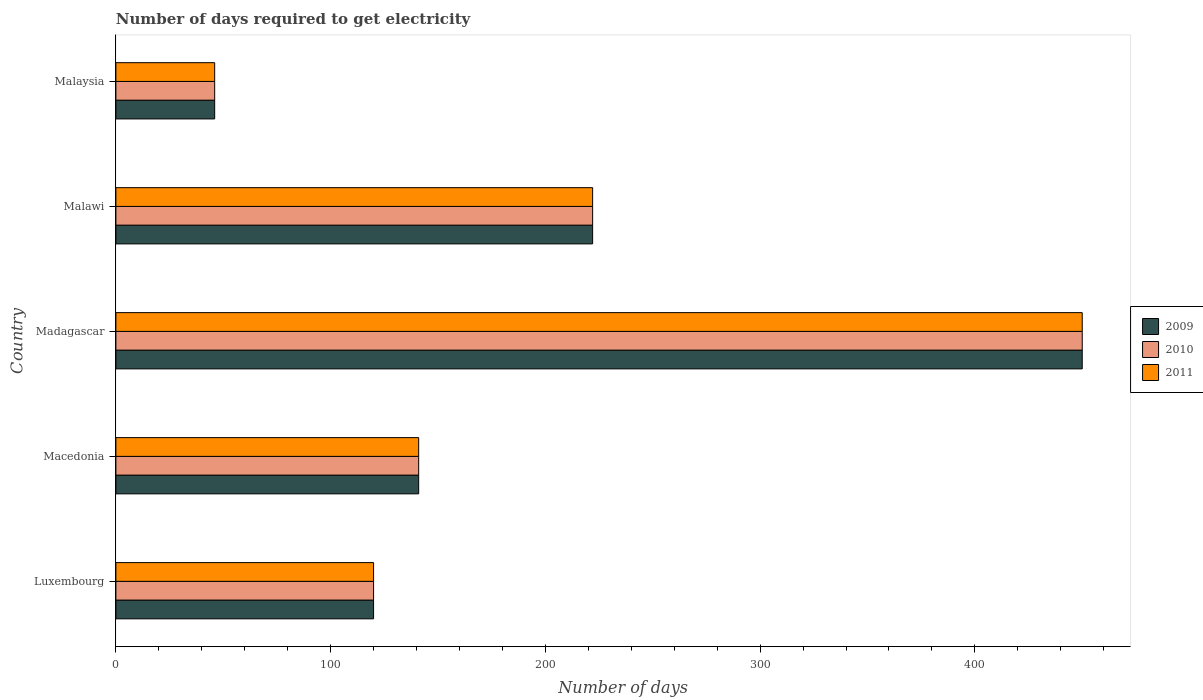How many different coloured bars are there?
Make the answer very short. 3. How many groups of bars are there?
Provide a short and direct response. 5. Are the number of bars per tick equal to the number of legend labels?
Offer a very short reply. Yes. Are the number of bars on each tick of the Y-axis equal?
Give a very brief answer. Yes. What is the label of the 5th group of bars from the top?
Provide a short and direct response. Luxembourg. In how many cases, is the number of bars for a given country not equal to the number of legend labels?
Offer a terse response. 0. Across all countries, what is the maximum number of days required to get electricity in in 2011?
Ensure brevity in your answer.  450. In which country was the number of days required to get electricity in in 2010 maximum?
Keep it short and to the point. Madagascar. In which country was the number of days required to get electricity in in 2011 minimum?
Ensure brevity in your answer.  Malaysia. What is the total number of days required to get electricity in in 2011 in the graph?
Keep it short and to the point. 979. What is the difference between the number of days required to get electricity in in 2010 in Luxembourg and that in Macedonia?
Provide a succinct answer. -21. What is the difference between the number of days required to get electricity in in 2011 in Malaysia and the number of days required to get electricity in in 2009 in Macedonia?
Ensure brevity in your answer.  -95. What is the average number of days required to get electricity in in 2010 per country?
Your answer should be very brief. 195.8. What is the ratio of the number of days required to get electricity in in 2010 in Madagascar to that in Malaysia?
Make the answer very short. 9.78. What is the difference between the highest and the second highest number of days required to get electricity in in 2010?
Your response must be concise. 228. What is the difference between the highest and the lowest number of days required to get electricity in in 2010?
Give a very brief answer. 404. What does the 2nd bar from the bottom in Malaysia represents?
Offer a terse response. 2010. Is it the case that in every country, the sum of the number of days required to get electricity in in 2009 and number of days required to get electricity in in 2010 is greater than the number of days required to get electricity in in 2011?
Keep it short and to the point. Yes. How many bars are there?
Make the answer very short. 15. Are all the bars in the graph horizontal?
Make the answer very short. Yes. What is the difference between two consecutive major ticks on the X-axis?
Your answer should be very brief. 100. Are the values on the major ticks of X-axis written in scientific E-notation?
Make the answer very short. No. Does the graph contain any zero values?
Offer a very short reply. No. Does the graph contain grids?
Your answer should be compact. No. What is the title of the graph?
Your answer should be very brief. Number of days required to get electricity. Does "2009" appear as one of the legend labels in the graph?
Your response must be concise. Yes. What is the label or title of the X-axis?
Offer a terse response. Number of days. What is the label or title of the Y-axis?
Your answer should be compact. Country. What is the Number of days in 2009 in Luxembourg?
Your answer should be compact. 120. What is the Number of days in 2010 in Luxembourg?
Make the answer very short. 120. What is the Number of days of 2011 in Luxembourg?
Give a very brief answer. 120. What is the Number of days in 2009 in Macedonia?
Offer a very short reply. 141. What is the Number of days in 2010 in Macedonia?
Provide a short and direct response. 141. What is the Number of days of 2011 in Macedonia?
Give a very brief answer. 141. What is the Number of days of 2009 in Madagascar?
Make the answer very short. 450. What is the Number of days of 2010 in Madagascar?
Offer a very short reply. 450. What is the Number of days of 2011 in Madagascar?
Your response must be concise. 450. What is the Number of days of 2009 in Malawi?
Your response must be concise. 222. What is the Number of days of 2010 in Malawi?
Give a very brief answer. 222. What is the Number of days of 2011 in Malawi?
Your answer should be compact. 222. What is the Number of days in 2009 in Malaysia?
Give a very brief answer. 46. What is the Number of days of 2010 in Malaysia?
Your response must be concise. 46. Across all countries, what is the maximum Number of days of 2009?
Your answer should be very brief. 450. Across all countries, what is the maximum Number of days in 2010?
Make the answer very short. 450. Across all countries, what is the maximum Number of days in 2011?
Keep it short and to the point. 450. Across all countries, what is the minimum Number of days in 2010?
Provide a short and direct response. 46. What is the total Number of days of 2009 in the graph?
Keep it short and to the point. 979. What is the total Number of days of 2010 in the graph?
Provide a succinct answer. 979. What is the total Number of days in 2011 in the graph?
Ensure brevity in your answer.  979. What is the difference between the Number of days in 2009 in Luxembourg and that in Madagascar?
Your response must be concise. -330. What is the difference between the Number of days of 2010 in Luxembourg and that in Madagascar?
Your response must be concise. -330. What is the difference between the Number of days of 2011 in Luxembourg and that in Madagascar?
Your answer should be very brief. -330. What is the difference between the Number of days in 2009 in Luxembourg and that in Malawi?
Offer a terse response. -102. What is the difference between the Number of days of 2010 in Luxembourg and that in Malawi?
Your answer should be very brief. -102. What is the difference between the Number of days in 2011 in Luxembourg and that in Malawi?
Make the answer very short. -102. What is the difference between the Number of days in 2010 in Luxembourg and that in Malaysia?
Your answer should be compact. 74. What is the difference between the Number of days of 2009 in Macedonia and that in Madagascar?
Your response must be concise. -309. What is the difference between the Number of days in 2010 in Macedonia and that in Madagascar?
Keep it short and to the point. -309. What is the difference between the Number of days of 2011 in Macedonia and that in Madagascar?
Offer a terse response. -309. What is the difference between the Number of days in 2009 in Macedonia and that in Malawi?
Offer a very short reply. -81. What is the difference between the Number of days in 2010 in Macedonia and that in Malawi?
Offer a terse response. -81. What is the difference between the Number of days of 2011 in Macedonia and that in Malawi?
Offer a very short reply. -81. What is the difference between the Number of days in 2010 in Macedonia and that in Malaysia?
Offer a terse response. 95. What is the difference between the Number of days of 2011 in Macedonia and that in Malaysia?
Provide a succinct answer. 95. What is the difference between the Number of days of 2009 in Madagascar and that in Malawi?
Give a very brief answer. 228. What is the difference between the Number of days of 2010 in Madagascar and that in Malawi?
Make the answer very short. 228. What is the difference between the Number of days in 2011 in Madagascar and that in Malawi?
Your answer should be very brief. 228. What is the difference between the Number of days in 2009 in Madagascar and that in Malaysia?
Make the answer very short. 404. What is the difference between the Number of days in 2010 in Madagascar and that in Malaysia?
Ensure brevity in your answer.  404. What is the difference between the Number of days in 2011 in Madagascar and that in Malaysia?
Make the answer very short. 404. What is the difference between the Number of days in 2009 in Malawi and that in Malaysia?
Keep it short and to the point. 176. What is the difference between the Number of days in 2010 in Malawi and that in Malaysia?
Your answer should be compact. 176. What is the difference between the Number of days in 2011 in Malawi and that in Malaysia?
Keep it short and to the point. 176. What is the difference between the Number of days of 2009 in Luxembourg and the Number of days of 2011 in Macedonia?
Provide a short and direct response. -21. What is the difference between the Number of days in 2009 in Luxembourg and the Number of days in 2010 in Madagascar?
Your answer should be compact. -330. What is the difference between the Number of days of 2009 in Luxembourg and the Number of days of 2011 in Madagascar?
Offer a terse response. -330. What is the difference between the Number of days of 2010 in Luxembourg and the Number of days of 2011 in Madagascar?
Your answer should be compact. -330. What is the difference between the Number of days in 2009 in Luxembourg and the Number of days in 2010 in Malawi?
Offer a very short reply. -102. What is the difference between the Number of days of 2009 in Luxembourg and the Number of days of 2011 in Malawi?
Offer a terse response. -102. What is the difference between the Number of days in 2010 in Luxembourg and the Number of days in 2011 in Malawi?
Your answer should be very brief. -102. What is the difference between the Number of days of 2009 in Macedonia and the Number of days of 2010 in Madagascar?
Your answer should be very brief. -309. What is the difference between the Number of days of 2009 in Macedonia and the Number of days of 2011 in Madagascar?
Provide a succinct answer. -309. What is the difference between the Number of days in 2010 in Macedonia and the Number of days in 2011 in Madagascar?
Offer a terse response. -309. What is the difference between the Number of days of 2009 in Macedonia and the Number of days of 2010 in Malawi?
Give a very brief answer. -81. What is the difference between the Number of days of 2009 in Macedonia and the Number of days of 2011 in Malawi?
Offer a terse response. -81. What is the difference between the Number of days in 2010 in Macedonia and the Number of days in 2011 in Malawi?
Offer a very short reply. -81. What is the difference between the Number of days in 2009 in Madagascar and the Number of days in 2010 in Malawi?
Provide a succinct answer. 228. What is the difference between the Number of days of 2009 in Madagascar and the Number of days of 2011 in Malawi?
Keep it short and to the point. 228. What is the difference between the Number of days of 2010 in Madagascar and the Number of days of 2011 in Malawi?
Ensure brevity in your answer.  228. What is the difference between the Number of days in 2009 in Madagascar and the Number of days in 2010 in Malaysia?
Your answer should be compact. 404. What is the difference between the Number of days in 2009 in Madagascar and the Number of days in 2011 in Malaysia?
Ensure brevity in your answer.  404. What is the difference between the Number of days of 2010 in Madagascar and the Number of days of 2011 in Malaysia?
Your answer should be compact. 404. What is the difference between the Number of days in 2009 in Malawi and the Number of days in 2010 in Malaysia?
Your answer should be compact. 176. What is the difference between the Number of days of 2009 in Malawi and the Number of days of 2011 in Malaysia?
Your response must be concise. 176. What is the difference between the Number of days in 2010 in Malawi and the Number of days in 2011 in Malaysia?
Give a very brief answer. 176. What is the average Number of days of 2009 per country?
Make the answer very short. 195.8. What is the average Number of days in 2010 per country?
Offer a very short reply. 195.8. What is the average Number of days of 2011 per country?
Make the answer very short. 195.8. What is the difference between the Number of days of 2010 and Number of days of 2011 in Luxembourg?
Your response must be concise. 0. What is the difference between the Number of days in 2009 and Number of days in 2011 in Macedonia?
Provide a succinct answer. 0. What is the difference between the Number of days of 2009 and Number of days of 2010 in Madagascar?
Your answer should be compact. 0. What is the difference between the Number of days of 2009 and Number of days of 2010 in Malaysia?
Provide a succinct answer. 0. What is the difference between the Number of days in 2009 and Number of days in 2011 in Malaysia?
Ensure brevity in your answer.  0. What is the difference between the Number of days in 2010 and Number of days in 2011 in Malaysia?
Make the answer very short. 0. What is the ratio of the Number of days in 2009 in Luxembourg to that in Macedonia?
Give a very brief answer. 0.85. What is the ratio of the Number of days in 2010 in Luxembourg to that in Macedonia?
Provide a short and direct response. 0.85. What is the ratio of the Number of days of 2011 in Luxembourg to that in Macedonia?
Make the answer very short. 0.85. What is the ratio of the Number of days of 2009 in Luxembourg to that in Madagascar?
Provide a short and direct response. 0.27. What is the ratio of the Number of days in 2010 in Luxembourg to that in Madagascar?
Keep it short and to the point. 0.27. What is the ratio of the Number of days of 2011 in Luxembourg to that in Madagascar?
Offer a very short reply. 0.27. What is the ratio of the Number of days in 2009 in Luxembourg to that in Malawi?
Ensure brevity in your answer.  0.54. What is the ratio of the Number of days of 2010 in Luxembourg to that in Malawi?
Keep it short and to the point. 0.54. What is the ratio of the Number of days in 2011 in Luxembourg to that in Malawi?
Offer a very short reply. 0.54. What is the ratio of the Number of days in 2009 in Luxembourg to that in Malaysia?
Provide a succinct answer. 2.61. What is the ratio of the Number of days of 2010 in Luxembourg to that in Malaysia?
Provide a succinct answer. 2.61. What is the ratio of the Number of days of 2011 in Luxembourg to that in Malaysia?
Offer a terse response. 2.61. What is the ratio of the Number of days of 2009 in Macedonia to that in Madagascar?
Your answer should be compact. 0.31. What is the ratio of the Number of days of 2010 in Macedonia to that in Madagascar?
Make the answer very short. 0.31. What is the ratio of the Number of days in 2011 in Macedonia to that in Madagascar?
Offer a very short reply. 0.31. What is the ratio of the Number of days in 2009 in Macedonia to that in Malawi?
Ensure brevity in your answer.  0.64. What is the ratio of the Number of days of 2010 in Macedonia to that in Malawi?
Offer a very short reply. 0.64. What is the ratio of the Number of days in 2011 in Macedonia to that in Malawi?
Provide a succinct answer. 0.64. What is the ratio of the Number of days in 2009 in Macedonia to that in Malaysia?
Provide a succinct answer. 3.07. What is the ratio of the Number of days in 2010 in Macedonia to that in Malaysia?
Provide a succinct answer. 3.07. What is the ratio of the Number of days in 2011 in Macedonia to that in Malaysia?
Make the answer very short. 3.07. What is the ratio of the Number of days of 2009 in Madagascar to that in Malawi?
Offer a terse response. 2.03. What is the ratio of the Number of days in 2010 in Madagascar to that in Malawi?
Ensure brevity in your answer.  2.03. What is the ratio of the Number of days in 2011 in Madagascar to that in Malawi?
Your answer should be compact. 2.03. What is the ratio of the Number of days of 2009 in Madagascar to that in Malaysia?
Provide a short and direct response. 9.78. What is the ratio of the Number of days in 2010 in Madagascar to that in Malaysia?
Give a very brief answer. 9.78. What is the ratio of the Number of days in 2011 in Madagascar to that in Malaysia?
Offer a very short reply. 9.78. What is the ratio of the Number of days of 2009 in Malawi to that in Malaysia?
Your answer should be compact. 4.83. What is the ratio of the Number of days in 2010 in Malawi to that in Malaysia?
Provide a succinct answer. 4.83. What is the ratio of the Number of days in 2011 in Malawi to that in Malaysia?
Your answer should be very brief. 4.83. What is the difference between the highest and the second highest Number of days in 2009?
Provide a succinct answer. 228. What is the difference between the highest and the second highest Number of days of 2010?
Offer a terse response. 228. What is the difference between the highest and the second highest Number of days of 2011?
Offer a very short reply. 228. What is the difference between the highest and the lowest Number of days of 2009?
Your response must be concise. 404. What is the difference between the highest and the lowest Number of days of 2010?
Your answer should be very brief. 404. What is the difference between the highest and the lowest Number of days in 2011?
Give a very brief answer. 404. 